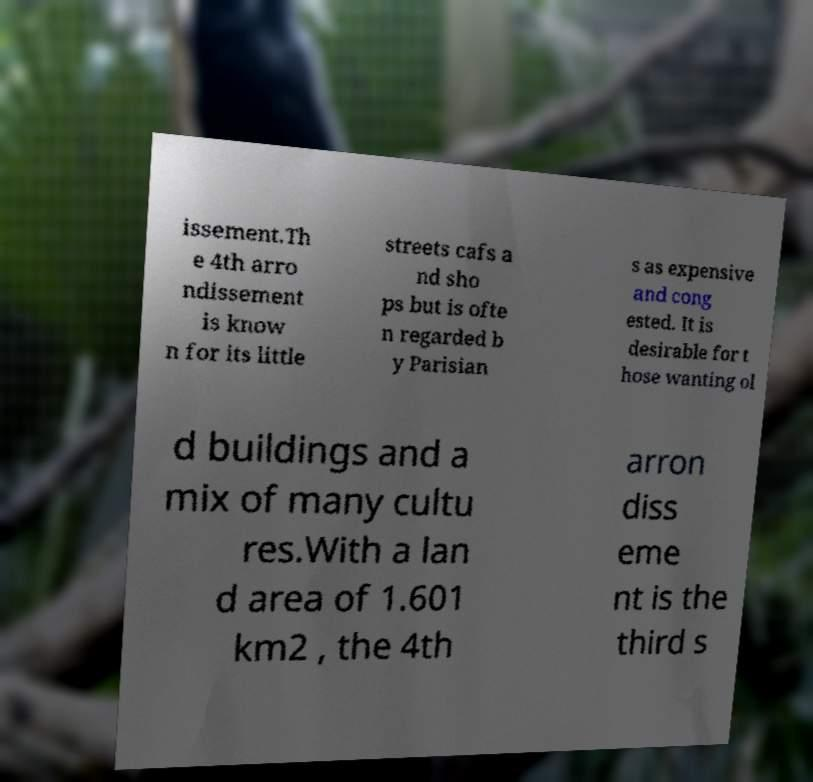There's text embedded in this image that I need extracted. Can you transcribe it verbatim? issement.Th e 4th arro ndissement is know n for its little streets cafs a nd sho ps but is ofte n regarded b y Parisian s as expensive and cong ested. It is desirable for t hose wanting ol d buildings and a mix of many cultu res.With a lan d area of 1.601 km2 , the 4th arron diss eme nt is the third s 